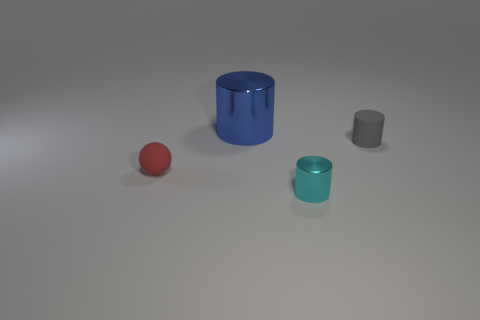Are there any other things that are the same shape as the red thing?
Offer a very short reply. No. How many other objects are there of the same size as the blue thing?
Offer a very short reply. 0. Is the big blue cylinder made of the same material as the cyan cylinder that is in front of the large blue thing?
Provide a succinct answer. Yes. Are there the same number of metallic cylinders that are to the right of the tiny metal cylinder and small cylinders that are in front of the small red ball?
Provide a succinct answer. No. What is the cyan object made of?
Provide a succinct answer. Metal. There is a metal cylinder that is the same size as the sphere; what is its color?
Offer a very short reply. Cyan. There is a cylinder behind the gray object; is there a tiny gray matte object in front of it?
Provide a succinct answer. Yes. How many blocks are gray objects or small cyan things?
Make the answer very short. 0. How big is the metal cylinder on the right side of the shiny cylinder on the left side of the metal thing in front of the red object?
Keep it short and to the point. Small. Are there any cylinders on the right side of the small metallic cylinder?
Your answer should be very brief. Yes. 